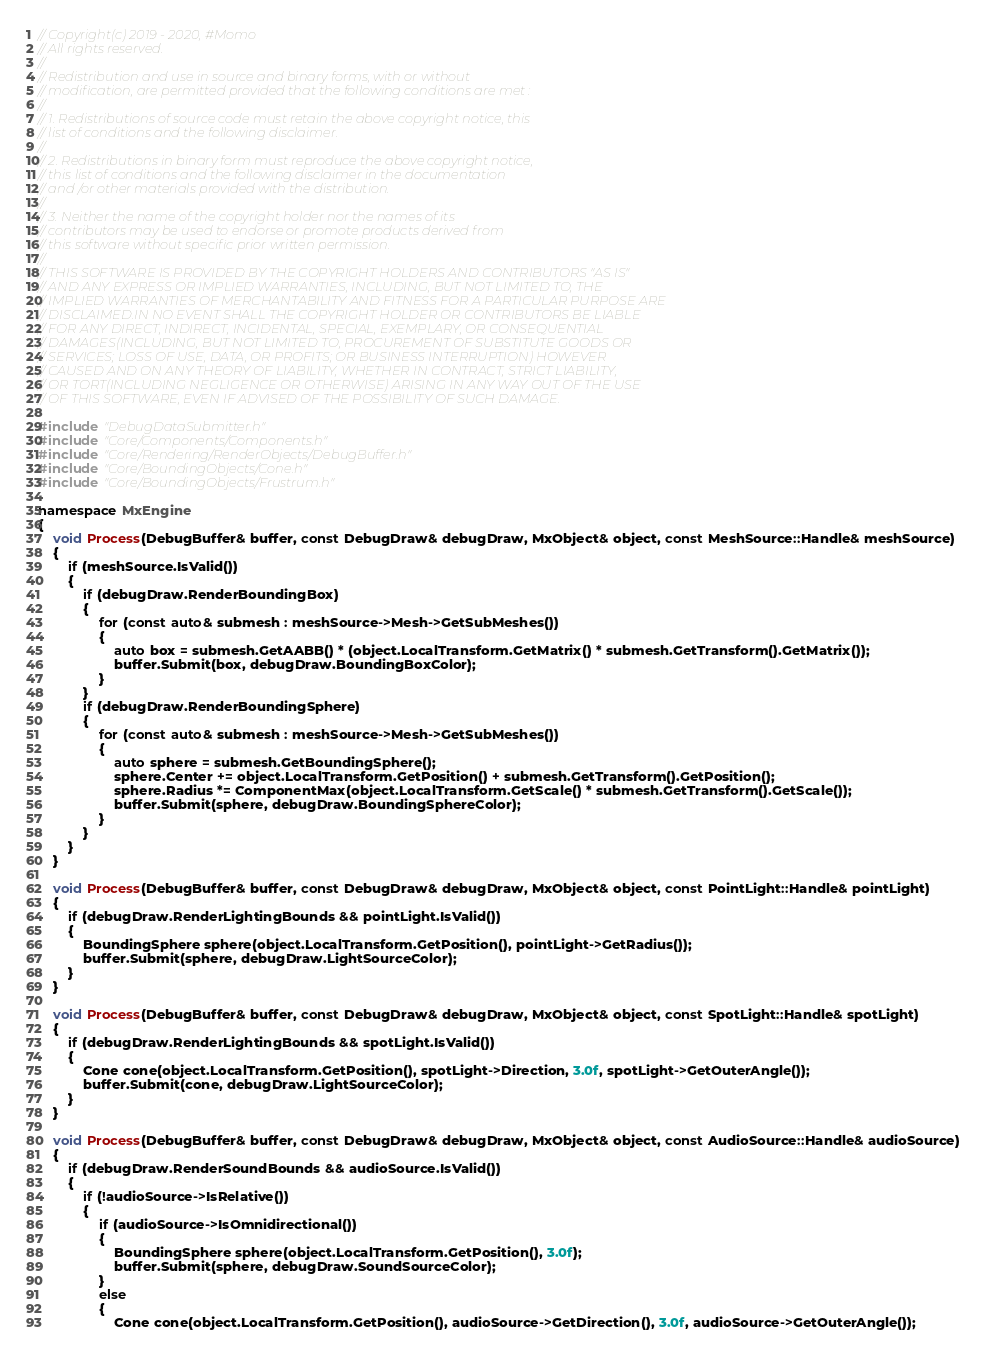<code> <loc_0><loc_0><loc_500><loc_500><_C++_>// Copyright(c) 2019 - 2020, #Momo
// All rights reserved.
// 
// Redistribution and use in source and binary forms, with or without
// modification, are permitted provided that the following conditions are met :
// 
// 1. Redistributions of source code must retain the above copyright notice, this
// list of conditions and the following disclaimer.
// 
// 2. Redistributions in binary form must reproduce the above copyright notice,
// this list of conditions and the following disclaimer in the documentation
// and /or other materials provided with the distribution.
// 
// 3. Neither the name of the copyright holder nor the names of its
// contributors may be used to endorse or promote products derived from
// this software without specific prior written permission.
// 
// THIS SOFTWARE IS PROVIDED BY THE COPYRIGHT HOLDERS AND CONTRIBUTORS "AS IS"
// AND ANY EXPRESS OR IMPLIED WARRANTIES, INCLUDING, BUT NOT LIMITED TO, THE
// IMPLIED WARRANTIES OF MERCHANTABILITY AND FITNESS FOR A PARTICULAR PURPOSE ARE
// DISCLAIMED.IN NO EVENT SHALL THE COPYRIGHT HOLDER OR CONTRIBUTORS BE LIABLE
// FOR ANY DIRECT, INDIRECT, INCIDENTAL, SPECIAL, EXEMPLARY, OR CONSEQUENTIAL
// DAMAGES(INCLUDING, BUT NOT LIMITED TO, PROCUREMENT OF SUBSTITUTE GOODS OR
// SERVICES; LOSS OF USE, DATA, OR PROFITS; OR BUSINESS INTERRUPTION) HOWEVER
// CAUSED AND ON ANY THEORY OF LIABILITY, WHETHER IN CONTRACT, STRICT LIABILITY,
// OR TORT(INCLUDING NEGLIGENCE OR OTHERWISE) ARISING IN ANY WAY OUT OF THE USE
// OF THIS SOFTWARE, EVEN IF ADVISED OF THE POSSIBILITY OF SUCH DAMAGE.

#include "DebugDataSubmitter.h"
#include "Core/Components/Components.h"
#include "Core/Rendering/RenderObjects/DebugBuffer.h"
#include "Core/BoundingObjects/Cone.h"
#include "Core/BoundingObjects/Frustrum.h"

namespace MxEngine
{
    void Process(DebugBuffer& buffer, const DebugDraw& debugDraw, MxObject& object, const MeshSource::Handle& meshSource)
    {
        if (meshSource.IsValid())
        {
            if (debugDraw.RenderBoundingBox)
            {
                for (const auto& submesh : meshSource->Mesh->GetSubMeshes())
                {
                    auto box = submesh.GetAABB() * (object.LocalTransform.GetMatrix() * submesh.GetTransform().GetMatrix());
                    buffer.Submit(box, debugDraw.BoundingBoxColor);
                }
            }
            if (debugDraw.RenderBoundingSphere)
            {
                for (const auto& submesh : meshSource->Mesh->GetSubMeshes())
                {
                    auto sphere = submesh.GetBoundingSphere();
                    sphere.Center += object.LocalTransform.GetPosition() + submesh.GetTransform().GetPosition();
                    sphere.Radius *= ComponentMax(object.LocalTransform.GetScale() * submesh.GetTransform().GetScale());
                    buffer.Submit(sphere, debugDraw.BoundingSphereColor);
                }
            }
        }
    }

    void Process(DebugBuffer& buffer, const DebugDraw& debugDraw, MxObject& object, const PointLight::Handle& pointLight)
    {
        if (debugDraw.RenderLightingBounds && pointLight.IsValid())
        {
            BoundingSphere sphere(object.LocalTransform.GetPosition(), pointLight->GetRadius());
            buffer.Submit(sphere, debugDraw.LightSourceColor);
        }
    }

    void Process(DebugBuffer& buffer, const DebugDraw& debugDraw, MxObject& object, const SpotLight::Handle& spotLight)
    {
        if (debugDraw.RenderLightingBounds && spotLight.IsValid())
        {
            Cone cone(object.LocalTransform.GetPosition(), spotLight->Direction, 3.0f, spotLight->GetOuterAngle());
            buffer.Submit(cone, debugDraw.LightSourceColor);
        }
    }

    void Process(DebugBuffer& buffer, const DebugDraw& debugDraw, MxObject& object, const AudioSource::Handle& audioSource)
    {
        if (debugDraw.RenderSoundBounds && audioSource.IsValid())
        {
            if (!audioSource->IsRelative())
            {
                if (audioSource->IsOmnidirectional())
                {
                    BoundingSphere sphere(object.LocalTransform.GetPosition(), 3.0f);
                    buffer.Submit(sphere, debugDraw.SoundSourceColor);
                }
                else
                {
                    Cone cone(object.LocalTransform.GetPosition(), audioSource->GetDirection(), 3.0f, audioSource->GetOuterAngle());</code> 